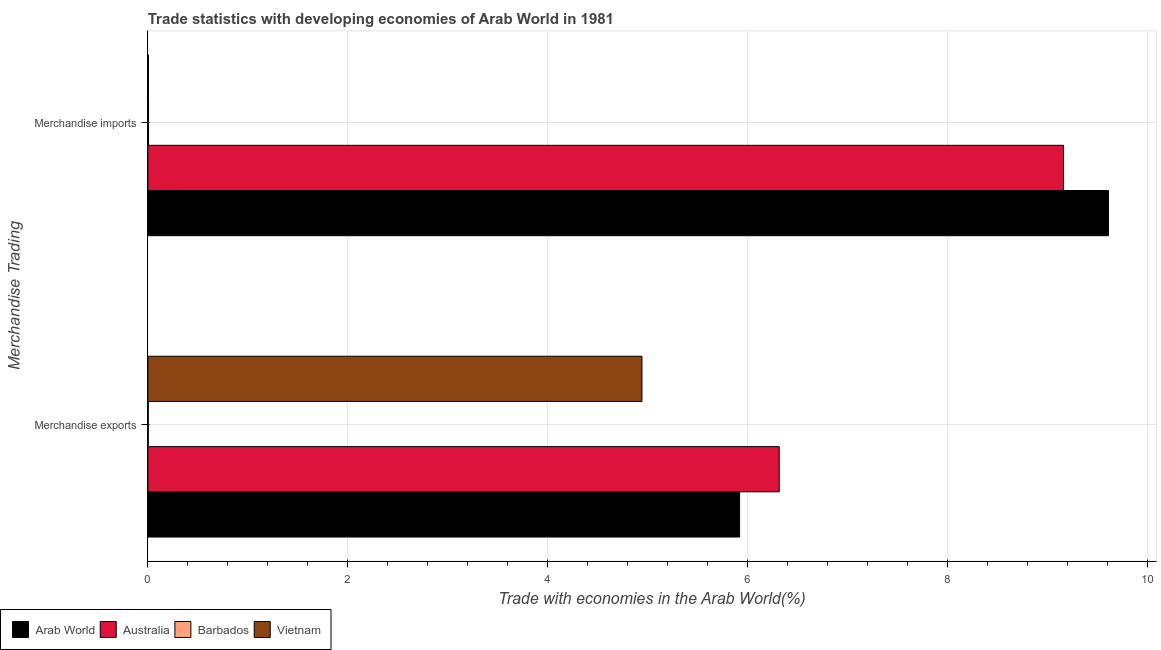How many groups of bars are there?
Provide a short and direct response. 2. How many bars are there on the 1st tick from the bottom?
Offer a terse response. 4. What is the label of the 2nd group of bars from the top?
Ensure brevity in your answer.  Merchandise exports. What is the merchandise imports in Vietnam?
Ensure brevity in your answer.  0.01. Across all countries, what is the maximum merchandise exports?
Give a very brief answer. 6.32. Across all countries, what is the minimum merchandise imports?
Keep it short and to the point. 0.01. In which country was the merchandise exports maximum?
Make the answer very short. Australia. In which country was the merchandise imports minimum?
Offer a very short reply. Vietnam. What is the total merchandise exports in the graph?
Your response must be concise. 17.18. What is the difference between the merchandise exports in Arab World and that in Barbados?
Give a very brief answer. 5.92. What is the difference between the merchandise imports in Vietnam and the merchandise exports in Australia?
Offer a very short reply. -6.31. What is the average merchandise imports per country?
Provide a short and direct response. 4.7. What is the difference between the merchandise exports and merchandise imports in Arab World?
Your answer should be compact. -3.69. What is the ratio of the merchandise imports in Vietnam to that in Australia?
Keep it short and to the point. 0. Is the merchandise exports in Australia less than that in Barbados?
Provide a short and direct response. No. What does the 2nd bar from the top in Merchandise imports represents?
Your answer should be very brief. Barbados. What does the 3rd bar from the bottom in Merchandise exports represents?
Make the answer very short. Barbados. How many bars are there?
Give a very brief answer. 8. How many countries are there in the graph?
Make the answer very short. 4. What is the difference between two consecutive major ticks on the X-axis?
Ensure brevity in your answer.  2. Does the graph contain grids?
Keep it short and to the point. Yes. Where does the legend appear in the graph?
Ensure brevity in your answer.  Bottom left. How are the legend labels stacked?
Keep it short and to the point. Horizontal. What is the title of the graph?
Make the answer very short. Trade statistics with developing economies of Arab World in 1981. What is the label or title of the X-axis?
Offer a terse response. Trade with economies in the Arab World(%). What is the label or title of the Y-axis?
Ensure brevity in your answer.  Merchandise Trading. What is the Trade with economies in the Arab World(%) in Arab World in Merchandise exports?
Give a very brief answer. 5.92. What is the Trade with economies in the Arab World(%) in Australia in Merchandise exports?
Provide a succinct answer. 6.32. What is the Trade with economies in the Arab World(%) in Barbados in Merchandise exports?
Ensure brevity in your answer.  0. What is the Trade with economies in the Arab World(%) of Vietnam in Merchandise exports?
Give a very brief answer. 4.94. What is the Trade with economies in the Arab World(%) of Arab World in Merchandise imports?
Offer a terse response. 9.61. What is the Trade with economies in the Arab World(%) of Australia in Merchandise imports?
Offer a terse response. 9.16. What is the Trade with economies in the Arab World(%) of Barbados in Merchandise imports?
Offer a terse response. 0.01. What is the Trade with economies in the Arab World(%) in Vietnam in Merchandise imports?
Provide a short and direct response. 0.01. Across all Merchandise Trading, what is the maximum Trade with economies in the Arab World(%) in Arab World?
Ensure brevity in your answer.  9.61. Across all Merchandise Trading, what is the maximum Trade with economies in the Arab World(%) in Australia?
Provide a short and direct response. 9.16. Across all Merchandise Trading, what is the maximum Trade with economies in the Arab World(%) of Barbados?
Provide a short and direct response. 0.01. Across all Merchandise Trading, what is the maximum Trade with economies in the Arab World(%) of Vietnam?
Offer a very short reply. 4.94. Across all Merchandise Trading, what is the minimum Trade with economies in the Arab World(%) in Arab World?
Ensure brevity in your answer.  5.92. Across all Merchandise Trading, what is the minimum Trade with economies in the Arab World(%) in Australia?
Ensure brevity in your answer.  6.32. Across all Merchandise Trading, what is the minimum Trade with economies in the Arab World(%) of Barbados?
Your response must be concise. 0. Across all Merchandise Trading, what is the minimum Trade with economies in the Arab World(%) in Vietnam?
Keep it short and to the point. 0.01. What is the total Trade with economies in the Arab World(%) in Arab World in the graph?
Your answer should be compact. 15.53. What is the total Trade with economies in the Arab World(%) in Australia in the graph?
Your answer should be very brief. 15.48. What is the total Trade with economies in the Arab World(%) in Barbados in the graph?
Ensure brevity in your answer.  0.01. What is the total Trade with economies in the Arab World(%) in Vietnam in the graph?
Give a very brief answer. 4.95. What is the difference between the Trade with economies in the Arab World(%) of Arab World in Merchandise exports and that in Merchandise imports?
Keep it short and to the point. -3.69. What is the difference between the Trade with economies in the Arab World(%) in Australia in Merchandise exports and that in Merchandise imports?
Provide a succinct answer. -2.84. What is the difference between the Trade with economies in the Arab World(%) of Barbados in Merchandise exports and that in Merchandise imports?
Offer a terse response. -0. What is the difference between the Trade with economies in the Arab World(%) of Vietnam in Merchandise exports and that in Merchandise imports?
Make the answer very short. 4.94. What is the difference between the Trade with economies in the Arab World(%) in Arab World in Merchandise exports and the Trade with economies in the Arab World(%) in Australia in Merchandise imports?
Ensure brevity in your answer.  -3.24. What is the difference between the Trade with economies in the Arab World(%) of Arab World in Merchandise exports and the Trade with economies in the Arab World(%) of Barbados in Merchandise imports?
Ensure brevity in your answer.  5.91. What is the difference between the Trade with economies in the Arab World(%) of Arab World in Merchandise exports and the Trade with economies in the Arab World(%) of Vietnam in Merchandise imports?
Provide a short and direct response. 5.91. What is the difference between the Trade with economies in the Arab World(%) in Australia in Merchandise exports and the Trade with economies in the Arab World(%) in Barbados in Merchandise imports?
Your response must be concise. 6.31. What is the difference between the Trade with economies in the Arab World(%) in Australia in Merchandise exports and the Trade with economies in the Arab World(%) in Vietnam in Merchandise imports?
Your response must be concise. 6.31. What is the difference between the Trade with economies in the Arab World(%) in Barbados in Merchandise exports and the Trade with economies in the Arab World(%) in Vietnam in Merchandise imports?
Make the answer very short. -0. What is the average Trade with economies in the Arab World(%) of Arab World per Merchandise Trading?
Make the answer very short. 7.77. What is the average Trade with economies in the Arab World(%) of Australia per Merchandise Trading?
Your answer should be compact. 7.74. What is the average Trade with economies in the Arab World(%) in Barbados per Merchandise Trading?
Your response must be concise. 0.01. What is the average Trade with economies in the Arab World(%) of Vietnam per Merchandise Trading?
Keep it short and to the point. 2.47. What is the difference between the Trade with economies in the Arab World(%) of Arab World and Trade with economies in the Arab World(%) of Australia in Merchandise exports?
Provide a short and direct response. -0.4. What is the difference between the Trade with economies in the Arab World(%) of Arab World and Trade with economies in the Arab World(%) of Barbados in Merchandise exports?
Your answer should be very brief. 5.92. What is the difference between the Trade with economies in the Arab World(%) in Australia and Trade with economies in the Arab World(%) in Barbados in Merchandise exports?
Keep it short and to the point. 6.31. What is the difference between the Trade with economies in the Arab World(%) in Australia and Trade with economies in the Arab World(%) in Vietnam in Merchandise exports?
Ensure brevity in your answer.  1.37. What is the difference between the Trade with economies in the Arab World(%) of Barbados and Trade with economies in the Arab World(%) of Vietnam in Merchandise exports?
Offer a very short reply. -4.94. What is the difference between the Trade with economies in the Arab World(%) of Arab World and Trade with economies in the Arab World(%) of Australia in Merchandise imports?
Make the answer very short. 0.45. What is the difference between the Trade with economies in the Arab World(%) of Arab World and Trade with economies in the Arab World(%) of Barbados in Merchandise imports?
Provide a short and direct response. 9.6. What is the difference between the Trade with economies in the Arab World(%) in Arab World and Trade with economies in the Arab World(%) in Vietnam in Merchandise imports?
Offer a very short reply. 9.6. What is the difference between the Trade with economies in the Arab World(%) in Australia and Trade with economies in the Arab World(%) in Barbados in Merchandise imports?
Ensure brevity in your answer.  9.15. What is the difference between the Trade with economies in the Arab World(%) of Australia and Trade with economies in the Arab World(%) of Vietnam in Merchandise imports?
Keep it short and to the point. 9.16. What is the ratio of the Trade with economies in the Arab World(%) in Arab World in Merchandise exports to that in Merchandise imports?
Your answer should be very brief. 0.62. What is the ratio of the Trade with economies in the Arab World(%) of Australia in Merchandise exports to that in Merchandise imports?
Give a very brief answer. 0.69. What is the ratio of the Trade with economies in the Arab World(%) in Barbados in Merchandise exports to that in Merchandise imports?
Give a very brief answer. 0.6. What is the ratio of the Trade with economies in the Arab World(%) of Vietnam in Merchandise exports to that in Merchandise imports?
Offer a terse response. 847.41. What is the difference between the highest and the second highest Trade with economies in the Arab World(%) of Arab World?
Make the answer very short. 3.69. What is the difference between the highest and the second highest Trade with economies in the Arab World(%) in Australia?
Give a very brief answer. 2.84. What is the difference between the highest and the second highest Trade with economies in the Arab World(%) in Barbados?
Give a very brief answer. 0. What is the difference between the highest and the second highest Trade with economies in the Arab World(%) of Vietnam?
Your answer should be compact. 4.94. What is the difference between the highest and the lowest Trade with economies in the Arab World(%) of Arab World?
Ensure brevity in your answer.  3.69. What is the difference between the highest and the lowest Trade with economies in the Arab World(%) in Australia?
Provide a short and direct response. 2.84. What is the difference between the highest and the lowest Trade with economies in the Arab World(%) in Barbados?
Provide a succinct answer. 0. What is the difference between the highest and the lowest Trade with economies in the Arab World(%) of Vietnam?
Keep it short and to the point. 4.94. 